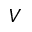<formula> <loc_0><loc_0><loc_500><loc_500>V</formula> 